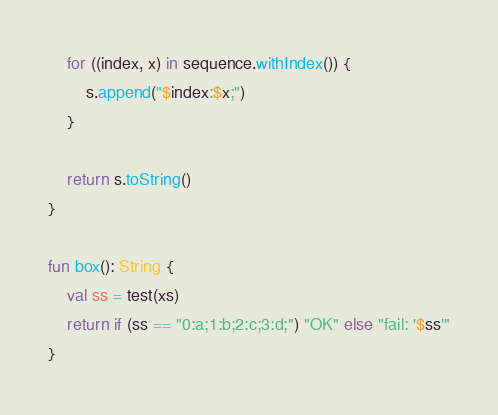Convert code to text. <code><loc_0><loc_0><loc_500><loc_500><_Kotlin_>
    for ((index, x) in sequence.withIndex()) {
        s.append("$index:$x;")
    }

    return s.toString()
}

fun box(): String {
    val ss = test(xs)
    return if (ss == "0:a;1:b;2:c;3:d;") "OK" else "fail: '$ss'"
}</code> 